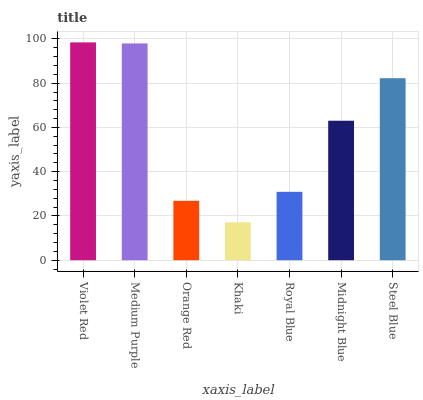Is Medium Purple the minimum?
Answer yes or no. No. Is Medium Purple the maximum?
Answer yes or no. No. Is Violet Red greater than Medium Purple?
Answer yes or no. Yes. Is Medium Purple less than Violet Red?
Answer yes or no. Yes. Is Medium Purple greater than Violet Red?
Answer yes or no. No. Is Violet Red less than Medium Purple?
Answer yes or no. No. Is Midnight Blue the high median?
Answer yes or no. Yes. Is Midnight Blue the low median?
Answer yes or no. Yes. Is Violet Red the high median?
Answer yes or no. No. Is Medium Purple the low median?
Answer yes or no. No. 